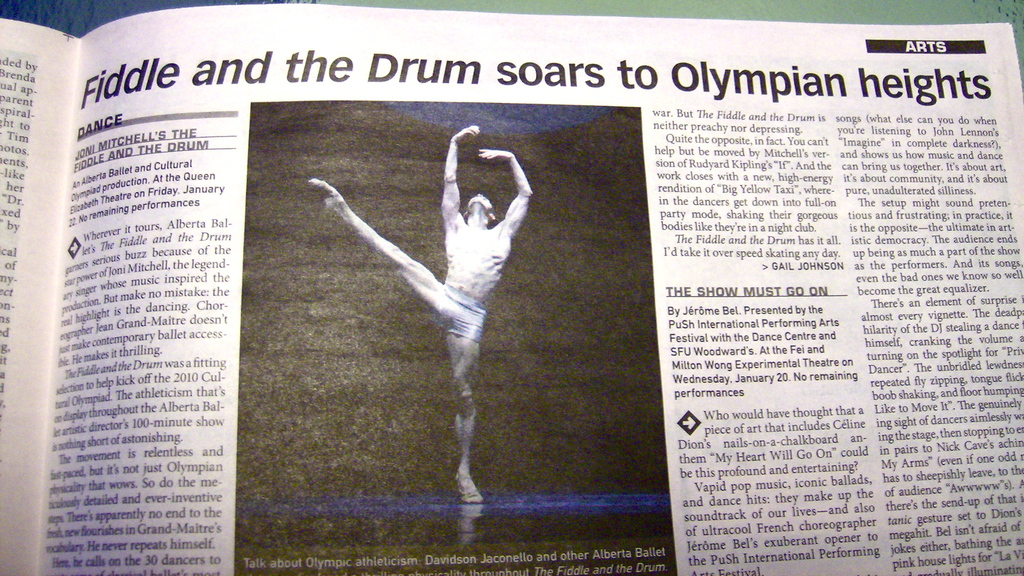Provide a one-sentence caption for the provided image. The image shows a newspaper article from the Arts section, highlighting a performance by a male ballet dancer in 'Fiddle and the Drum', a show which explores themes of war and peace, receiving high praise for its Olympian heights of athleticism and emotion. 